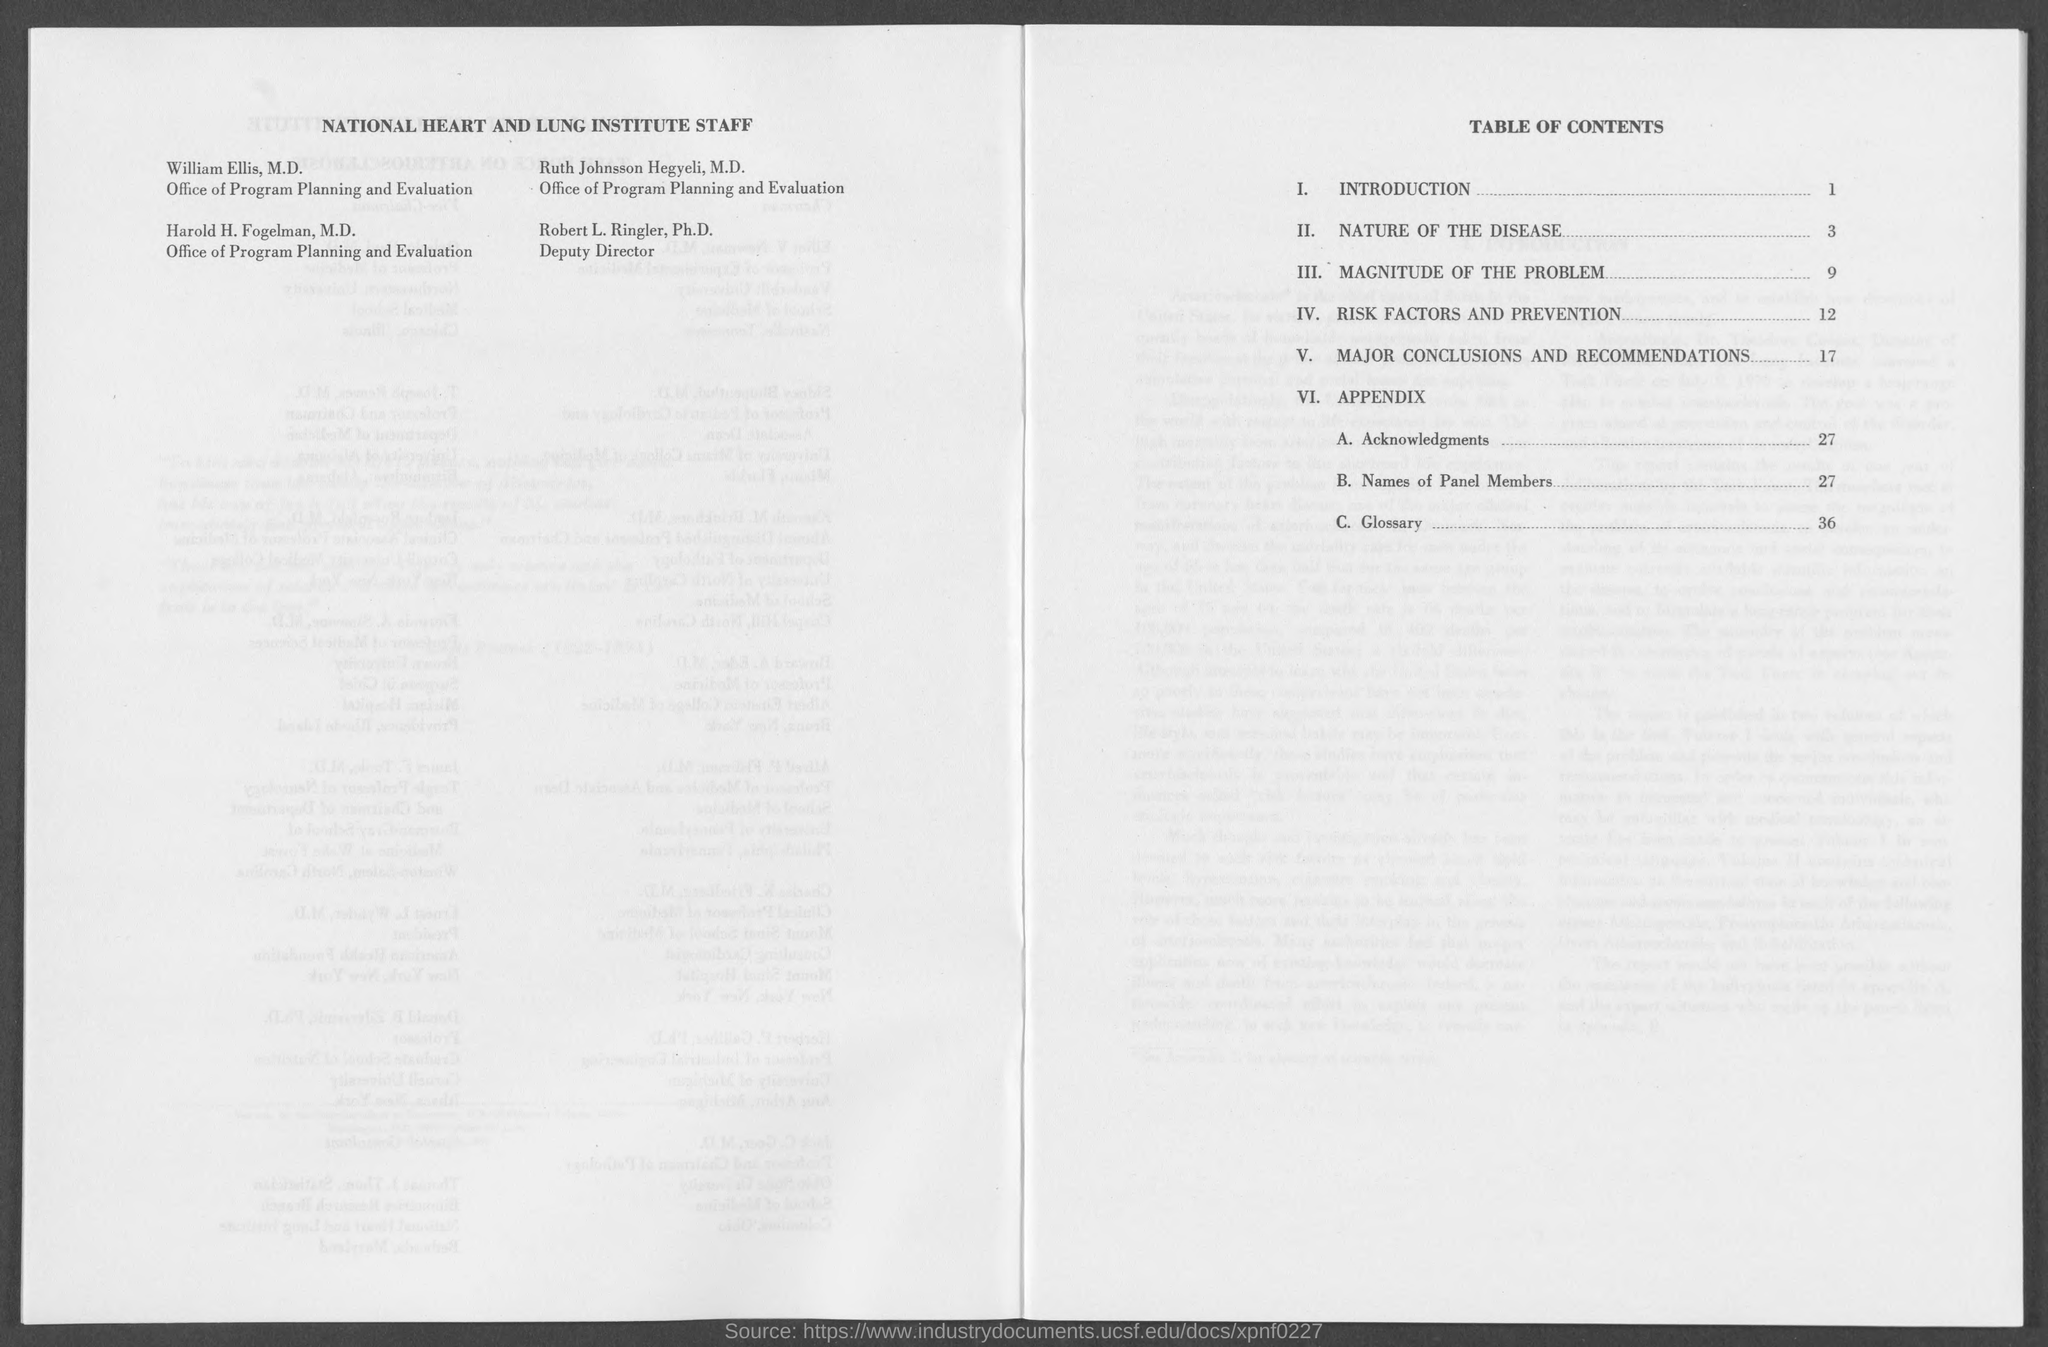What is the position of robert l. ringler, ph.d?
Give a very brief answer. Deputy director. 